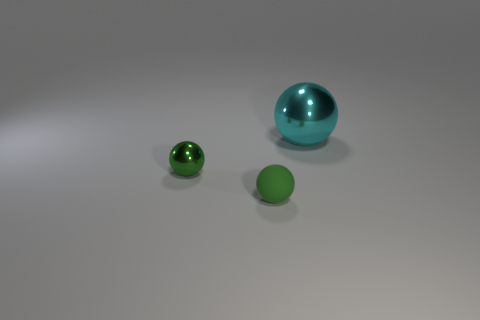Subtract all large cyan metal spheres. How many spheres are left? 2 Subtract all green spheres. How many spheres are left? 1 Subtract 2 spheres. How many spheres are left? 1 Add 2 rubber spheres. How many objects exist? 5 Add 1 tiny metallic balls. How many tiny metallic balls exist? 2 Subtract 1 cyan balls. How many objects are left? 2 Subtract all green spheres. Subtract all cyan blocks. How many spheres are left? 1 Subtract all cyan cubes. How many green spheres are left? 2 Subtract all cyan objects. Subtract all yellow rubber spheres. How many objects are left? 2 Add 1 small metal objects. How many small metal objects are left? 2 